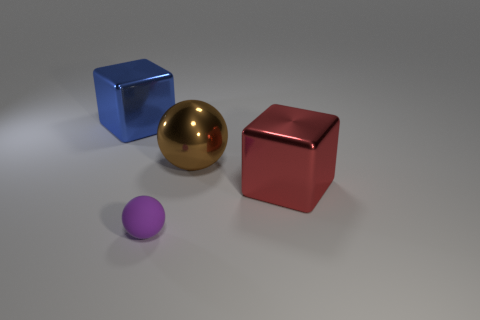Is the material of the large thing that is in front of the brown object the same as the sphere in front of the red metal thing?
Your answer should be very brief. No. What number of shiny things are small balls or large cubes?
Offer a terse response. 2. There is a metal block on the right side of the brown ball; how many brown metal balls are right of it?
Ensure brevity in your answer.  0. How many cubes have the same material as the brown sphere?
Your answer should be compact. 2. How many tiny objects are either blue shiny objects or purple matte objects?
Offer a terse response. 1. There is a object that is both in front of the big blue block and behind the large red metal object; what is its shape?
Keep it short and to the point. Sphere. Are the large blue cube and the big brown object made of the same material?
Provide a short and direct response. Yes. What color is the ball that is the same size as the blue metal object?
Offer a very short reply. Brown. There is a object that is both right of the blue object and to the left of the large metal sphere; what is its color?
Ensure brevity in your answer.  Purple. There is a metallic cube in front of the large cube to the left of the ball that is in front of the big red metallic block; what size is it?
Ensure brevity in your answer.  Large. 